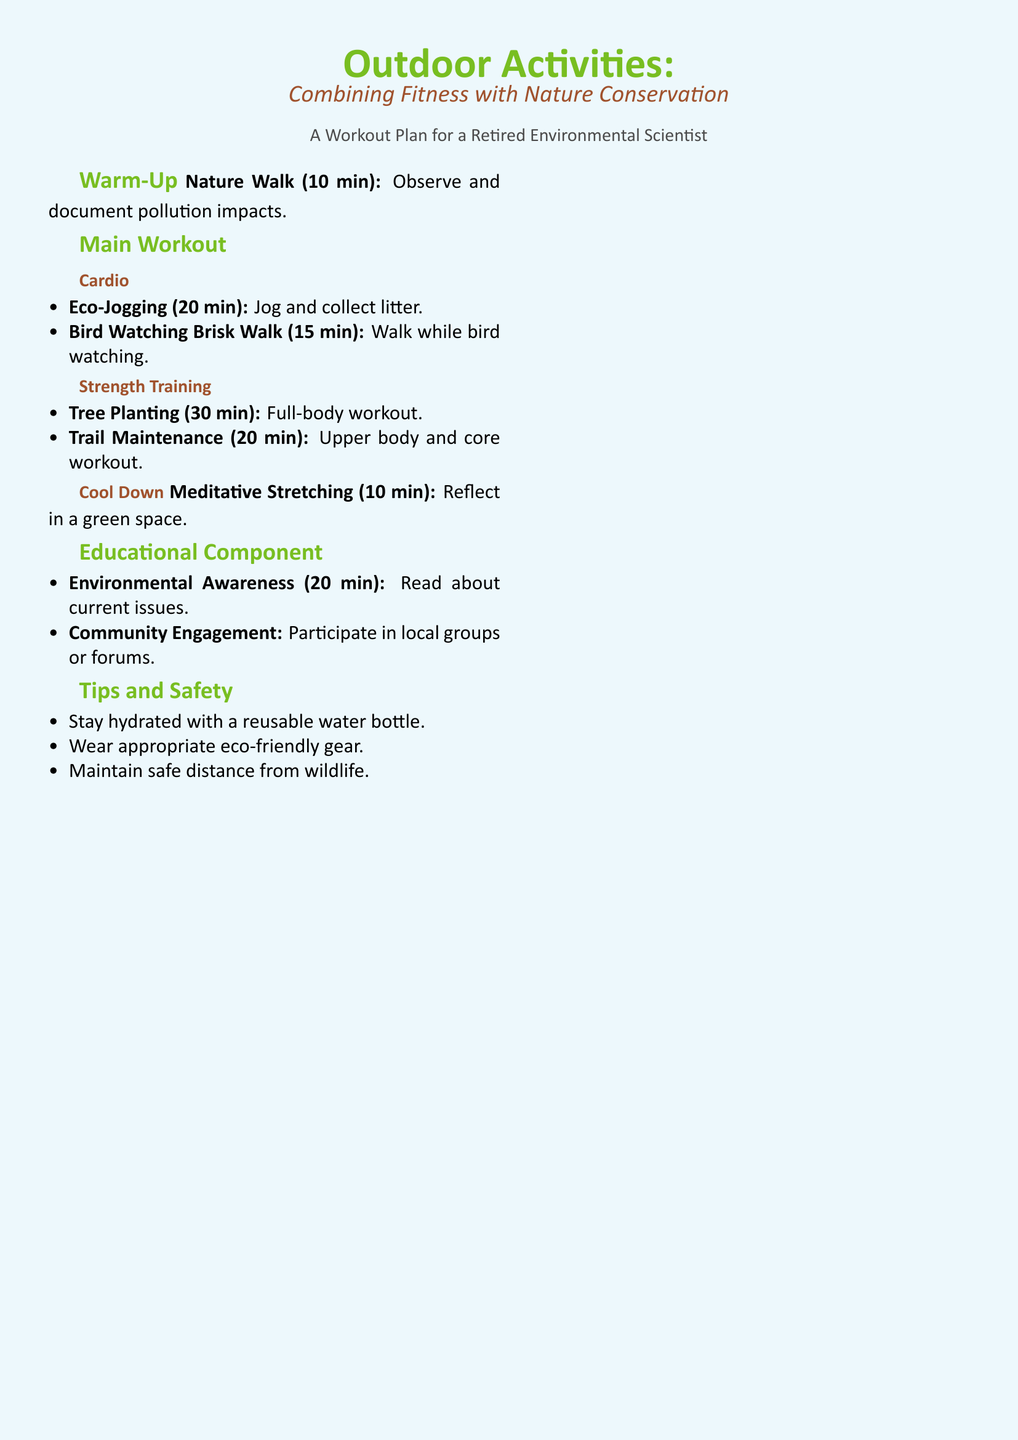What is the duration of the warm-up activity? The duration of the warm-up activity is specified as 10 minutes in the document.
Answer: 10 min How long is the Eco-Jogging session? The document states that Eco-Jogging lasts for 20 minutes.
Answer: 20 min What type of exercise is included in the cool down section? The cool down section features Meditative Stretching which is designed to help reflect.
Answer: Meditative Stretching What is one of the strength training activities mentioned? The document lists Tree Planting as a strength training activity.
Answer: Tree Planting How long should one engage in Environmental Awareness reading? The reading on Environmental Awareness is suggested for a duration of 20 minutes.
Answer: 20 min What is a primary focus of the workout plan? The main focus of the workout plan is to combine fitness with nature conservation.
Answer: Nature conservation What should participants maintain a safe distance from? The document advises maintaining a safe distance from wildlife during activities.
Answer: Wildlife What is recommended for hydration during the workout? The document recommends using a reusable water bottle for hydration.
Answer: Reusable water bottle What is the total time for the main workout sections (Cardio and Strength Training)? The total time combines the various cardio and strength training activities which total 85 minutes; 20 + 15 + 30 + 20 = 85.
Answer: 85 min 